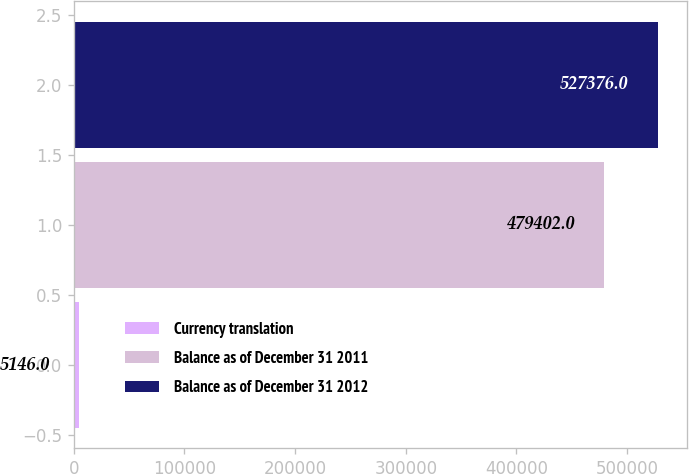Convert chart to OTSL. <chart><loc_0><loc_0><loc_500><loc_500><bar_chart><fcel>Currency translation<fcel>Balance as of December 31 2011<fcel>Balance as of December 31 2012<nl><fcel>5146<fcel>479402<fcel>527376<nl></chart> 